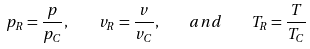Convert formula to latex. <formula><loc_0><loc_0><loc_500><loc_500>p _ { R } = { \frac { p } { p _ { C } } } , \quad v _ { R } = { \frac { v } { v _ { C } } } , \quad a n d \quad T _ { R } = { \frac { T } { T _ { C } } }</formula> 